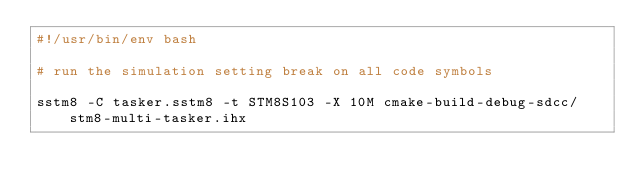Convert code to text. <code><loc_0><loc_0><loc_500><loc_500><_Bash_>#!/usr/bin/env bash

# run the simulation setting break on all code symbols

sstm8 -C tasker.sstm8 -t STM8S103 -X 10M cmake-build-debug-sdcc/stm8-multi-tasker.ihx


</code> 